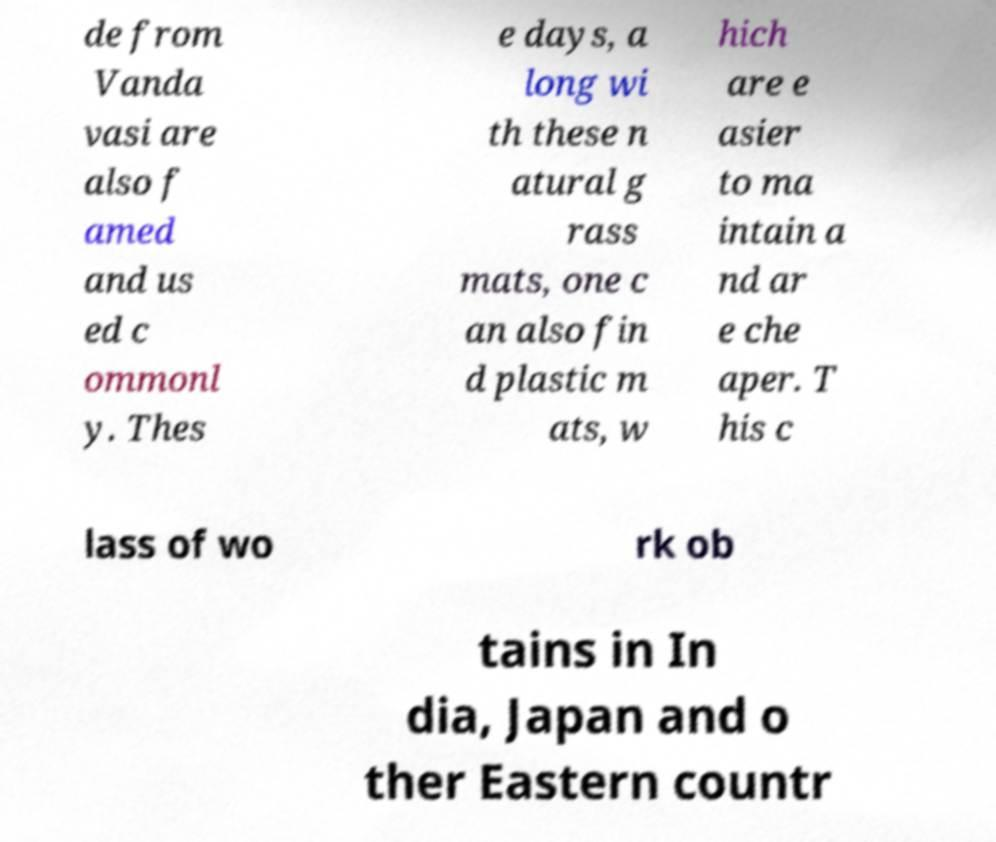Can you accurately transcribe the text from the provided image for me? de from Vanda vasi are also f amed and us ed c ommonl y. Thes e days, a long wi th these n atural g rass mats, one c an also fin d plastic m ats, w hich are e asier to ma intain a nd ar e che aper. T his c lass of wo rk ob tains in In dia, Japan and o ther Eastern countr 